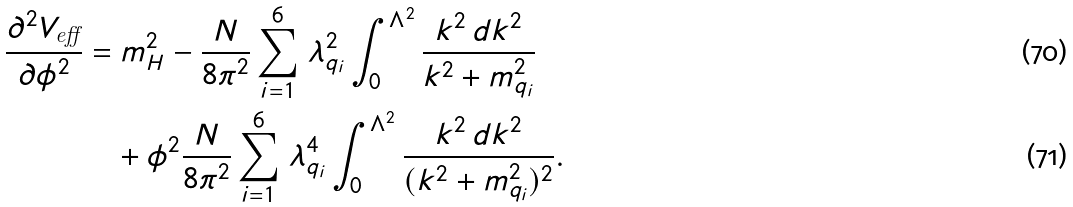Convert formula to latex. <formula><loc_0><loc_0><loc_500><loc_500>\frac { \partial ^ { 2 } V _ { \text {eff} } } { \partial \phi ^ { 2 } } & = m _ { H } ^ { 2 } - \frac { N } { 8 \pi ^ { 2 } } \sum _ { i = 1 } ^ { 6 } \, \lambda _ { q _ { i } } ^ { 2 } \int _ { 0 } ^ { \Lambda ^ { 2 } } \frac { k ^ { 2 } \, d k ^ { 2 } } { k ^ { 2 } + m _ { q _ { i } } ^ { 2 } } \\ & \quad + \phi ^ { 2 } \frac { N } { 8 \pi ^ { 2 } } \sum _ { i = 1 } ^ { 6 } \, \lambda _ { q _ { i } } ^ { 4 } \int _ { 0 } ^ { \Lambda ^ { 2 } } \frac { k ^ { 2 } \, d k ^ { 2 } } { ( k ^ { 2 } + m _ { q _ { i } } ^ { 2 } ) ^ { 2 } } .</formula> 